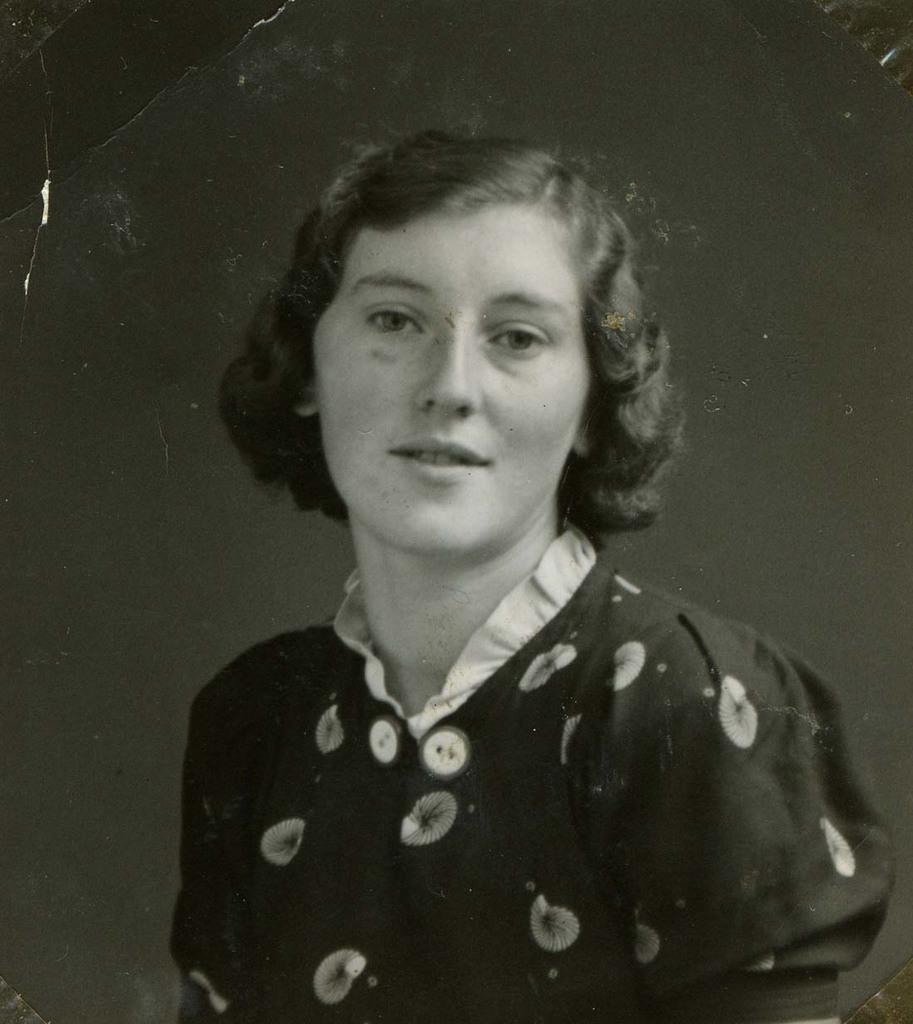What is the color scheme of the image? The image is in black and white. Who is the main subject in the image? There is a woman in the center of the image. What book is the woman reading in the image? There is no book present in the image; it is in black and white and features a woman in the center. How does the woman's behavior change throughout the image? The image is in black and white and does not depict any changes in behavior. 